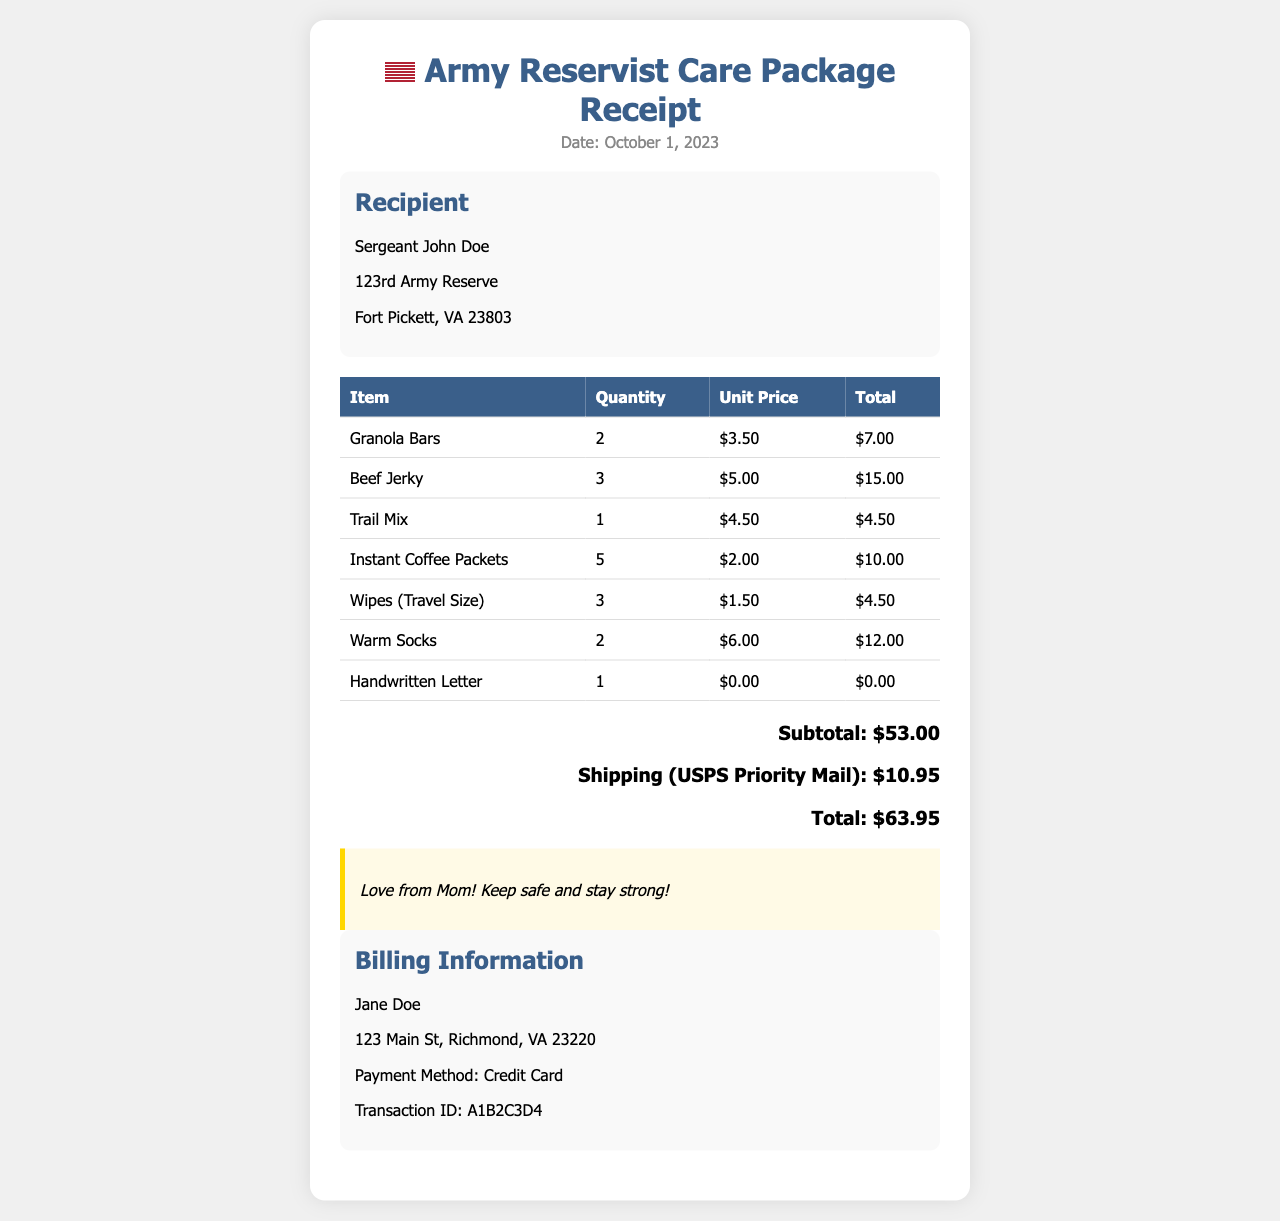what is the recipient's name? The recipient's name is mentioned in the document as Sergeant John Doe.
Answer: Sergeant John Doe what date was the care package sent? The date provided in the document indicates when the care package was sent, which is October 1, 2023.
Answer: October 1, 2023 how many granola bars were included? The document specifies that there were 2 granola bars included in the care package.
Answer: 2 what is the subtotal of the items? The subtotal is calculated by summing the total prices of all listed items, which is $53.00.
Answer: $53.00 what is the shipping cost? The document details the shipping cost as $10.95 for USPS Priority Mail.
Answer: $10.95 who is the sender of the care package? The sender's name is noted in the document as Jane Doe.
Answer: Jane Doe what is the total amount charged? The total amount charged for the care package, including shipping, is $63.95.
Answer: $63.95 how many items were listed in the care package? The document lists a total of 7 items included in the care package.
Answer: 7 what type of payment method was used? The payment method specified in the billing section is a Credit Card.
Answer: Credit Card 